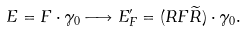Convert formula to latex. <formula><loc_0><loc_0><loc_500><loc_500>E = F \cdot \gamma _ { 0 } \longrightarrow E _ { F } ^ { \prime } = ( R F \widetilde { R } ) \cdot \gamma _ { 0 } .</formula> 